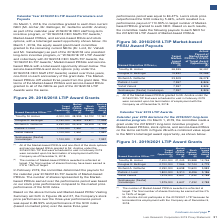According to Lam Research Corporation's financial document, What was the number of shares represented by the Marketbased PRSUs earned over the performance period based on? our stock price performance compared to the market price performance of the SOX index. The document states: "s earned over the performance period was based on our stock price performance compared to the market price performance of the SOX index...." Also, What was the Company's stock price performance over the three-year performance period? According to the financial document, 89.93%. The relevant text states: "ver the three-year performance period was equal to 89.93% and performance of the SOX index (based on market price) over the same three-year..." Also, How much did Lam's stock price outperform the SOX index by? According to the financial document, 5.46%. The relevant text states: "%. Lam’s stock price outperformed the SOX index by 5.46%, which resulted in a performance payout of 110.93% to target number of Market- based PRSUs granted..." Additionally, Which named executive officer has the highest target award opportunity? Based on the financial document, the answer is Timothy M.Archer. Additionally, Which named executive officer has the highest Market-based PRSUs award? Based on the financial document, the answer is Timothy M.Archer. Additionally, Which named executive officer has the highest Stock Options Award? Based on the financial document, the answer is Timothy M.Archer. 